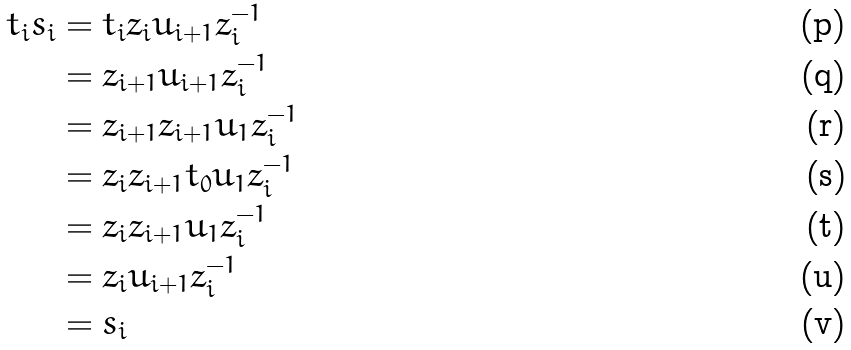<formula> <loc_0><loc_0><loc_500><loc_500>t _ { i } s _ { i } & = t _ { i } z _ { i } u _ { i + 1 } z _ { i } ^ { - 1 } \\ & = z _ { i + 1 } u _ { i + 1 } z _ { i } ^ { - 1 } \\ & = z _ { i + 1 } z _ { i + 1 } u _ { 1 } z _ { i } ^ { - 1 } \\ & = z _ { i } z _ { i + 1 } t _ { 0 } u _ { 1 } z _ { i } ^ { - 1 } \\ & = z _ { i } z _ { i + 1 } u _ { 1 } z _ { i } ^ { - 1 } \\ & = z _ { i } u _ { i + 1 } z _ { i } ^ { - 1 } \\ & = s _ { i }</formula> 